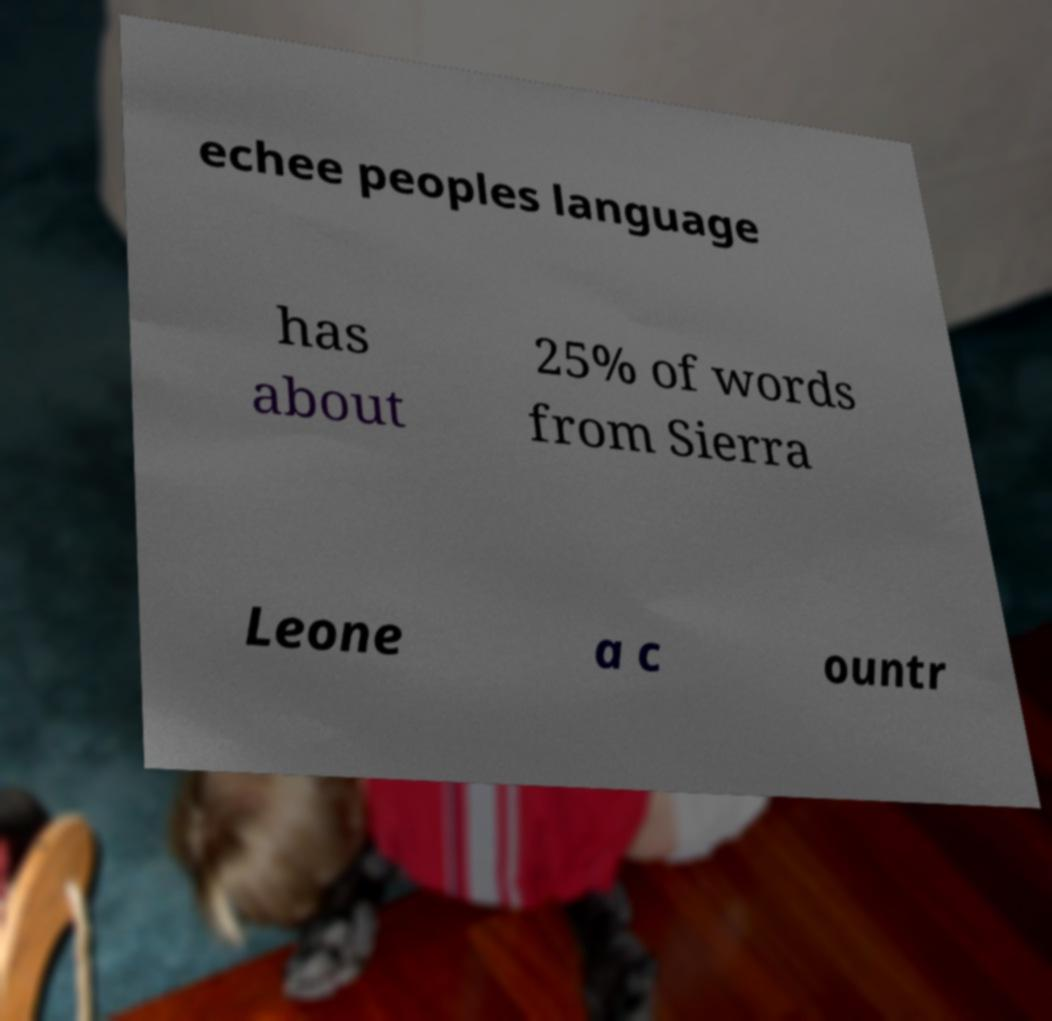I need the written content from this picture converted into text. Can you do that? echee peoples language has about 25% of words from Sierra Leone a c ountr 